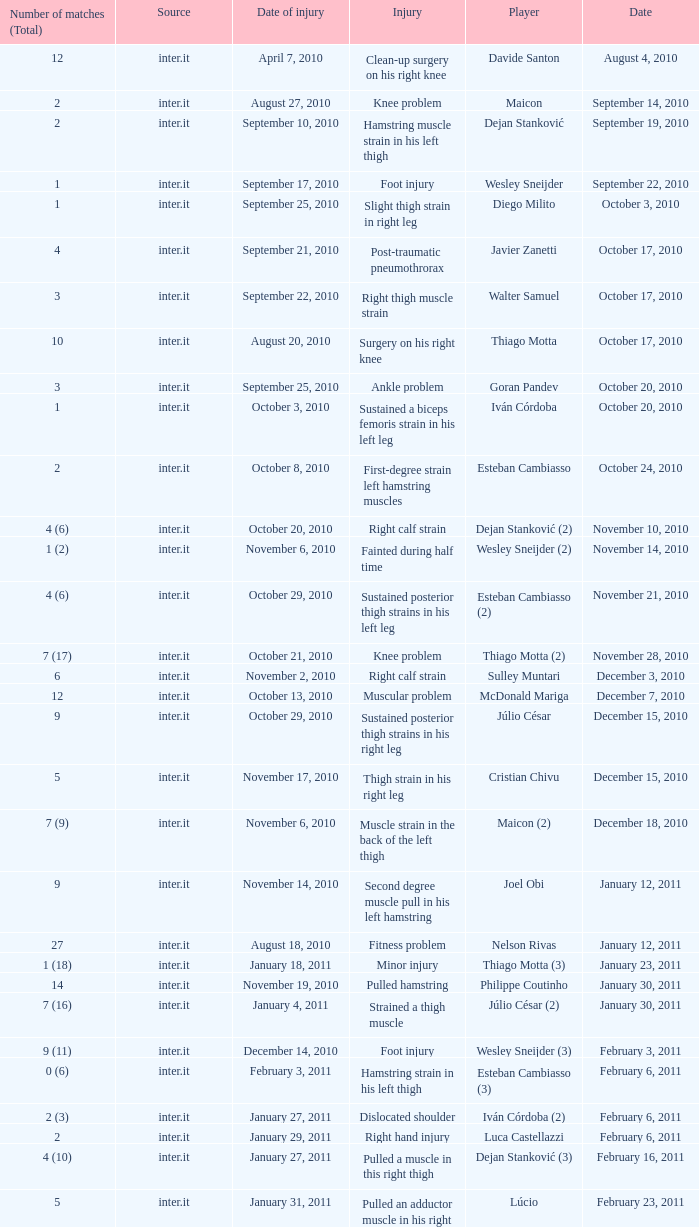What is the date of injury when the injury is foot injury and the number of matches (total) is 1? September 17, 2010. 